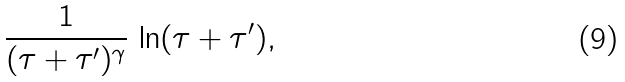Convert formula to latex. <formula><loc_0><loc_0><loc_500><loc_500>\frac { 1 } { ( \tau + \tau ^ { \prime } ) ^ { \gamma } } \, \ln ( \tau + \tau ^ { \prime } ) ,</formula> 